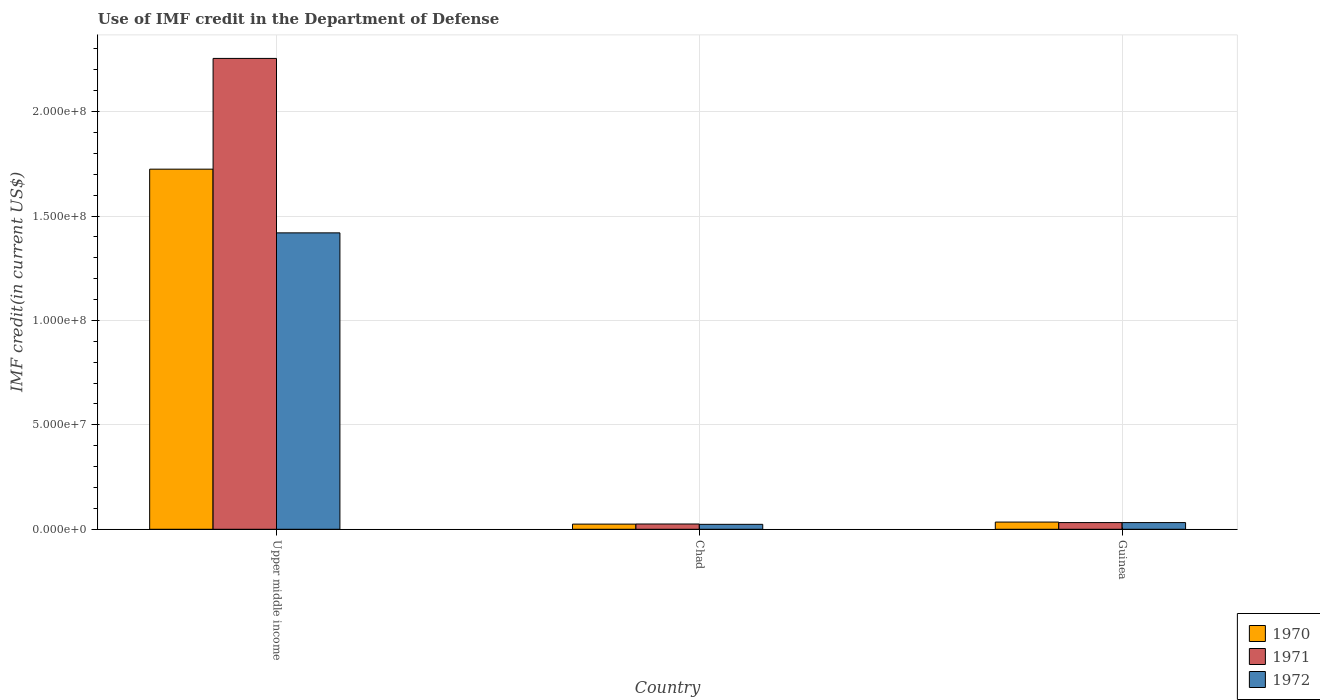How many different coloured bars are there?
Provide a short and direct response. 3. How many groups of bars are there?
Give a very brief answer. 3. Are the number of bars per tick equal to the number of legend labels?
Provide a succinct answer. Yes. What is the label of the 1st group of bars from the left?
Make the answer very short. Upper middle income. What is the IMF credit in the Department of Defense in 1972 in Guinea?
Provide a short and direct response. 3.20e+06. Across all countries, what is the maximum IMF credit in the Department of Defense in 1972?
Your response must be concise. 1.42e+08. Across all countries, what is the minimum IMF credit in the Department of Defense in 1971?
Ensure brevity in your answer.  2.52e+06. In which country was the IMF credit in the Department of Defense in 1971 maximum?
Your answer should be compact. Upper middle income. In which country was the IMF credit in the Department of Defense in 1970 minimum?
Give a very brief answer. Chad. What is the total IMF credit in the Department of Defense in 1970 in the graph?
Your answer should be compact. 1.78e+08. What is the difference between the IMF credit in the Department of Defense in 1970 in Chad and that in Guinea?
Give a very brief answer. -9.80e+05. What is the difference between the IMF credit in the Department of Defense in 1971 in Chad and the IMF credit in the Department of Defense in 1970 in Upper middle income?
Provide a short and direct response. -1.70e+08. What is the average IMF credit in the Department of Defense in 1971 per country?
Make the answer very short. 7.71e+07. What is the difference between the IMF credit in the Department of Defense of/in 1970 and IMF credit in the Department of Defense of/in 1972 in Guinea?
Offer a very short reply. 2.47e+05. In how many countries, is the IMF credit in the Department of Defense in 1971 greater than 20000000 US$?
Provide a succinct answer. 1. What is the ratio of the IMF credit in the Department of Defense in 1972 in Guinea to that in Upper middle income?
Give a very brief answer. 0.02. Is the IMF credit in the Department of Defense in 1970 in Chad less than that in Guinea?
Ensure brevity in your answer.  Yes. What is the difference between the highest and the second highest IMF credit in the Department of Defense in 1971?
Your answer should be compact. 2.22e+08. What is the difference between the highest and the lowest IMF credit in the Department of Defense in 1971?
Give a very brief answer. 2.23e+08. In how many countries, is the IMF credit in the Department of Defense in 1972 greater than the average IMF credit in the Department of Defense in 1972 taken over all countries?
Your answer should be compact. 1. Is the sum of the IMF credit in the Department of Defense in 1972 in Guinea and Upper middle income greater than the maximum IMF credit in the Department of Defense in 1970 across all countries?
Keep it short and to the point. No. What does the 2nd bar from the right in Guinea represents?
Offer a very short reply. 1971. Is it the case that in every country, the sum of the IMF credit in the Department of Defense in 1971 and IMF credit in the Department of Defense in 1970 is greater than the IMF credit in the Department of Defense in 1972?
Make the answer very short. Yes. Are all the bars in the graph horizontal?
Your response must be concise. No. How many countries are there in the graph?
Offer a very short reply. 3. Where does the legend appear in the graph?
Provide a short and direct response. Bottom right. How many legend labels are there?
Ensure brevity in your answer.  3. How are the legend labels stacked?
Provide a succinct answer. Vertical. What is the title of the graph?
Offer a very short reply. Use of IMF credit in the Department of Defense. Does "1974" appear as one of the legend labels in the graph?
Make the answer very short. No. What is the label or title of the Y-axis?
Offer a terse response. IMF credit(in current US$). What is the IMF credit(in current US$) of 1970 in Upper middle income?
Give a very brief answer. 1.72e+08. What is the IMF credit(in current US$) of 1971 in Upper middle income?
Your answer should be compact. 2.25e+08. What is the IMF credit(in current US$) of 1972 in Upper middle income?
Make the answer very short. 1.42e+08. What is the IMF credit(in current US$) in 1970 in Chad?
Your answer should be very brief. 2.47e+06. What is the IMF credit(in current US$) in 1971 in Chad?
Offer a terse response. 2.52e+06. What is the IMF credit(in current US$) of 1972 in Chad?
Offer a very short reply. 2.37e+06. What is the IMF credit(in current US$) in 1970 in Guinea?
Provide a succinct answer. 3.45e+06. What is the IMF credit(in current US$) in 1971 in Guinea?
Your answer should be compact. 3.20e+06. What is the IMF credit(in current US$) of 1972 in Guinea?
Ensure brevity in your answer.  3.20e+06. Across all countries, what is the maximum IMF credit(in current US$) in 1970?
Offer a very short reply. 1.72e+08. Across all countries, what is the maximum IMF credit(in current US$) in 1971?
Keep it short and to the point. 2.25e+08. Across all countries, what is the maximum IMF credit(in current US$) in 1972?
Keep it short and to the point. 1.42e+08. Across all countries, what is the minimum IMF credit(in current US$) in 1970?
Make the answer very short. 2.47e+06. Across all countries, what is the minimum IMF credit(in current US$) in 1971?
Offer a terse response. 2.52e+06. Across all countries, what is the minimum IMF credit(in current US$) in 1972?
Your answer should be compact. 2.37e+06. What is the total IMF credit(in current US$) of 1970 in the graph?
Provide a succinct answer. 1.78e+08. What is the total IMF credit(in current US$) of 1971 in the graph?
Your response must be concise. 2.31e+08. What is the total IMF credit(in current US$) in 1972 in the graph?
Give a very brief answer. 1.48e+08. What is the difference between the IMF credit(in current US$) in 1970 in Upper middle income and that in Chad?
Make the answer very short. 1.70e+08. What is the difference between the IMF credit(in current US$) in 1971 in Upper middle income and that in Chad?
Offer a very short reply. 2.23e+08. What is the difference between the IMF credit(in current US$) in 1972 in Upper middle income and that in Chad?
Keep it short and to the point. 1.40e+08. What is the difference between the IMF credit(in current US$) in 1970 in Upper middle income and that in Guinea?
Offer a very short reply. 1.69e+08. What is the difference between the IMF credit(in current US$) of 1971 in Upper middle income and that in Guinea?
Your response must be concise. 2.22e+08. What is the difference between the IMF credit(in current US$) of 1972 in Upper middle income and that in Guinea?
Make the answer very short. 1.39e+08. What is the difference between the IMF credit(in current US$) of 1970 in Chad and that in Guinea?
Give a very brief answer. -9.80e+05. What is the difference between the IMF credit(in current US$) in 1971 in Chad and that in Guinea?
Ensure brevity in your answer.  -6.84e+05. What is the difference between the IMF credit(in current US$) in 1972 in Chad and that in Guinea?
Keep it short and to the point. -8.36e+05. What is the difference between the IMF credit(in current US$) in 1970 in Upper middle income and the IMF credit(in current US$) in 1971 in Chad?
Offer a terse response. 1.70e+08. What is the difference between the IMF credit(in current US$) in 1970 in Upper middle income and the IMF credit(in current US$) in 1972 in Chad?
Provide a succinct answer. 1.70e+08. What is the difference between the IMF credit(in current US$) in 1971 in Upper middle income and the IMF credit(in current US$) in 1972 in Chad?
Your answer should be very brief. 2.23e+08. What is the difference between the IMF credit(in current US$) of 1970 in Upper middle income and the IMF credit(in current US$) of 1971 in Guinea?
Your response must be concise. 1.69e+08. What is the difference between the IMF credit(in current US$) in 1970 in Upper middle income and the IMF credit(in current US$) in 1972 in Guinea?
Offer a very short reply. 1.69e+08. What is the difference between the IMF credit(in current US$) of 1971 in Upper middle income and the IMF credit(in current US$) of 1972 in Guinea?
Offer a terse response. 2.22e+08. What is the difference between the IMF credit(in current US$) in 1970 in Chad and the IMF credit(in current US$) in 1971 in Guinea?
Ensure brevity in your answer.  -7.33e+05. What is the difference between the IMF credit(in current US$) of 1970 in Chad and the IMF credit(in current US$) of 1972 in Guinea?
Provide a short and direct response. -7.33e+05. What is the difference between the IMF credit(in current US$) in 1971 in Chad and the IMF credit(in current US$) in 1972 in Guinea?
Your response must be concise. -6.84e+05. What is the average IMF credit(in current US$) of 1970 per country?
Your answer should be very brief. 5.95e+07. What is the average IMF credit(in current US$) in 1971 per country?
Give a very brief answer. 7.71e+07. What is the average IMF credit(in current US$) of 1972 per country?
Ensure brevity in your answer.  4.92e+07. What is the difference between the IMF credit(in current US$) in 1970 and IMF credit(in current US$) in 1971 in Upper middle income?
Your answer should be very brief. -5.30e+07. What is the difference between the IMF credit(in current US$) in 1970 and IMF credit(in current US$) in 1972 in Upper middle income?
Ensure brevity in your answer.  3.05e+07. What is the difference between the IMF credit(in current US$) of 1971 and IMF credit(in current US$) of 1972 in Upper middle income?
Provide a short and direct response. 8.35e+07. What is the difference between the IMF credit(in current US$) in 1970 and IMF credit(in current US$) in 1971 in Chad?
Keep it short and to the point. -4.90e+04. What is the difference between the IMF credit(in current US$) of 1970 and IMF credit(in current US$) of 1972 in Chad?
Provide a short and direct response. 1.03e+05. What is the difference between the IMF credit(in current US$) of 1971 and IMF credit(in current US$) of 1972 in Chad?
Give a very brief answer. 1.52e+05. What is the difference between the IMF credit(in current US$) of 1970 and IMF credit(in current US$) of 1971 in Guinea?
Provide a succinct answer. 2.47e+05. What is the difference between the IMF credit(in current US$) in 1970 and IMF credit(in current US$) in 1972 in Guinea?
Your answer should be very brief. 2.47e+05. What is the difference between the IMF credit(in current US$) in 1971 and IMF credit(in current US$) in 1972 in Guinea?
Provide a short and direct response. 0. What is the ratio of the IMF credit(in current US$) in 1970 in Upper middle income to that in Chad?
Make the answer very short. 69.82. What is the ratio of the IMF credit(in current US$) in 1971 in Upper middle income to that in Chad?
Offer a terse response. 89.51. What is the ratio of the IMF credit(in current US$) in 1972 in Upper middle income to that in Chad?
Offer a terse response. 59.97. What is the ratio of the IMF credit(in current US$) of 1970 in Upper middle income to that in Guinea?
Provide a short and direct response. 49.99. What is the ratio of the IMF credit(in current US$) in 1971 in Upper middle income to that in Guinea?
Your response must be concise. 70.4. What is the ratio of the IMF credit(in current US$) of 1972 in Upper middle income to that in Guinea?
Keep it short and to the point. 44.32. What is the ratio of the IMF credit(in current US$) of 1970 in Chad to that in Guinea?
Your answer should be very brief. 0.72. What is the ratio of the IMF credit(in current US$) of 1971 in Chad to that in Guinea?
Ensure brevity in your answer.  0.79. What is the ratio of the IMF credit(in current US$) in 1972 in Chad to that in Guinea?
Give a very brief answer. 0.74. What is the difference between the highest and the second highest IMF credit(in current US$) in 1970?
Give a very brief answer. 1.69e+08. What is the difference between the highest and the second highest IMF credit(in current US$) of 1971?
Provide a short and direct response. 2.22e+08. What is the difference between the highest and the second highest IMF credit(in current US$) in 1972?
Your answer should be very brief. 1.39e+08. What is the difference between the highest and the lowest IMF credit(in current US$) in 1970?
Make the answer very short. 1.70e+08. What is the difference between the highest and the lowest IMF credit(in current US$) of 1971?
Provide a short and direct response. 2.23e+08. What is the difference between the highest and the lowest IMF credit(in current US$) of 1972?
Offer a very short reply. 1.40e+08. 